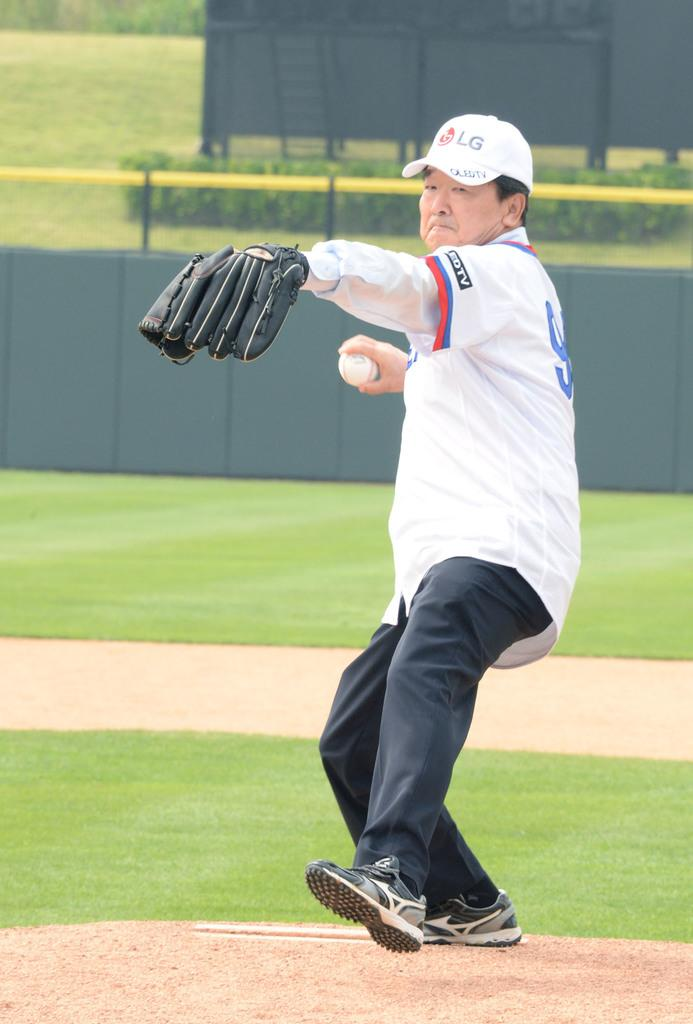<image>
Share a concise interpretation of the image provided. A man throwing a baseball in a LEDTV hat and jersey. 